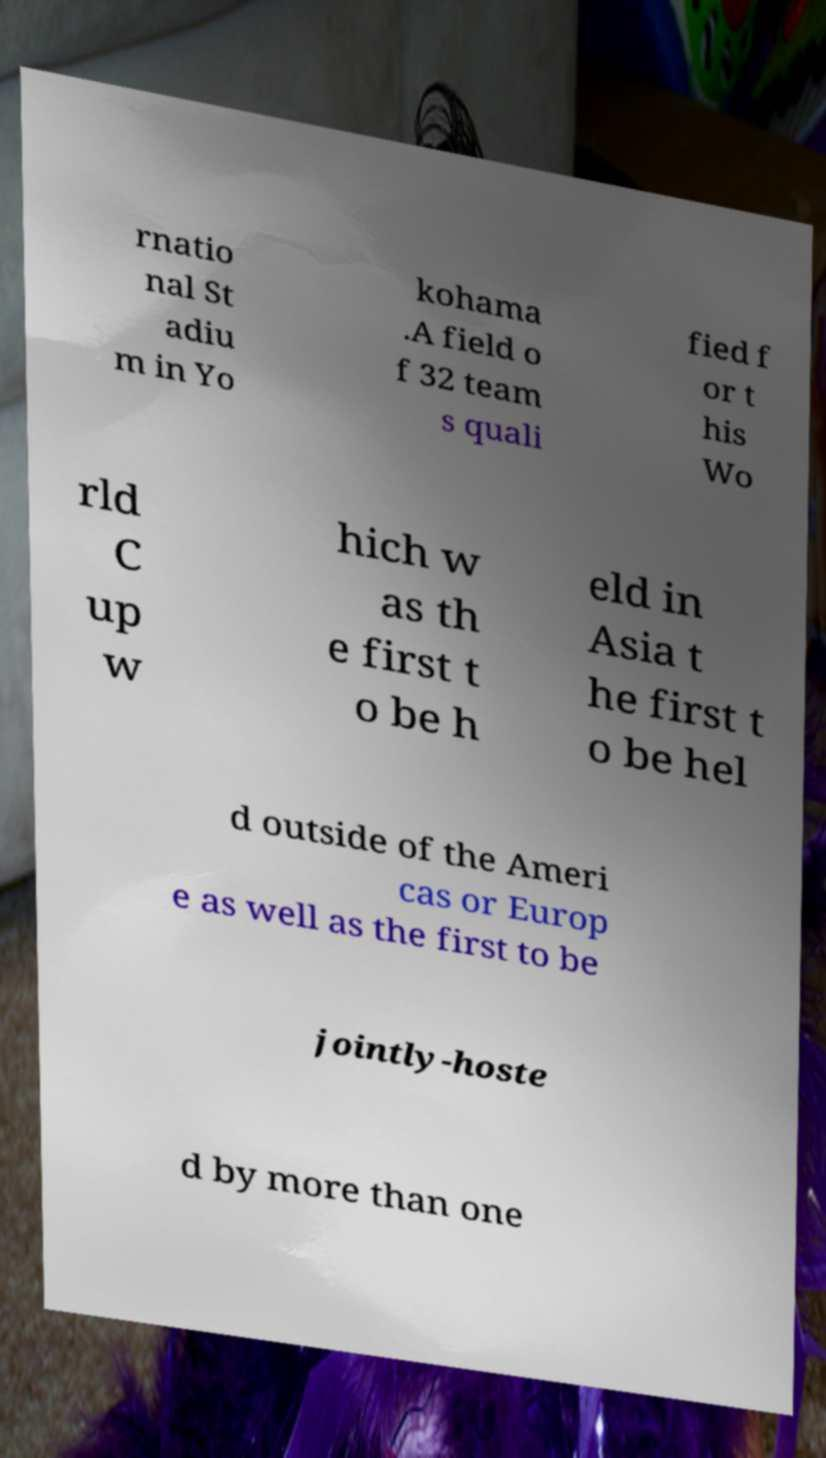Could you assist in decoding the text presented in this image and type it out clearly? rnatio nal St adiu m in Yo kohama .A field o f 32 team s quali fied f or t his Wo rld C up w hich w as th e first t o be h eld in Asia t he first t o be hel d outside of the Ameri cas or Europ e as well as the first to be jointly-hoste d by more than one 